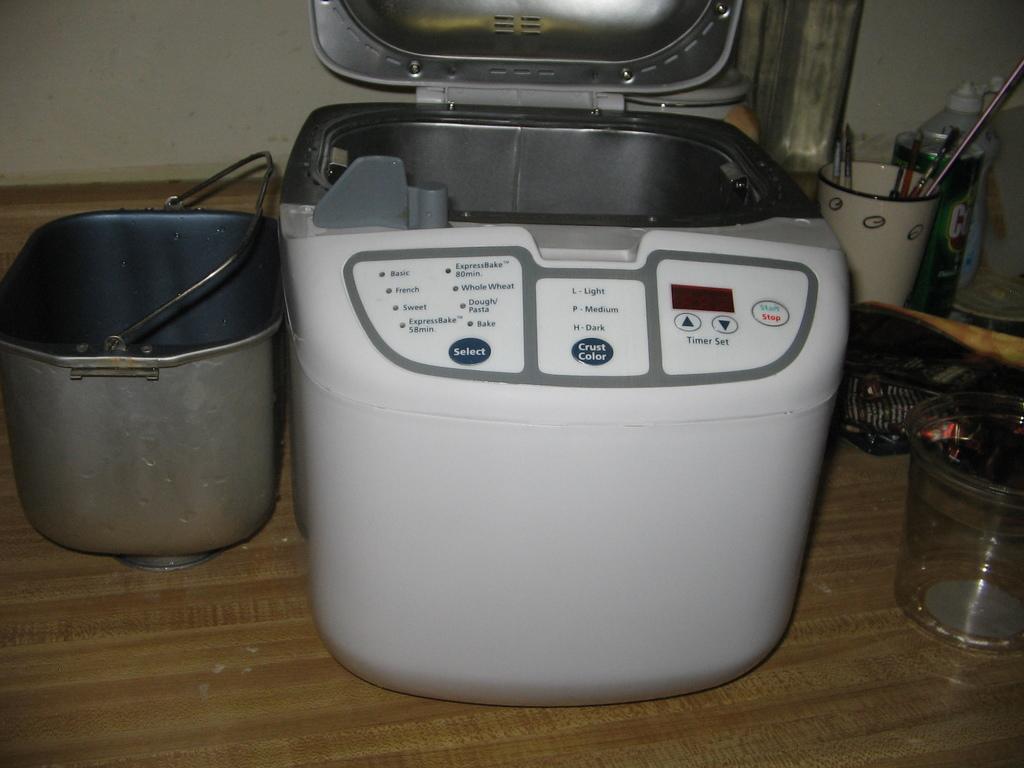Could you give a brief overview of what you see in this image? In this picture we can see a bucket, machine, a glass, cup and other things on the flat surface. 